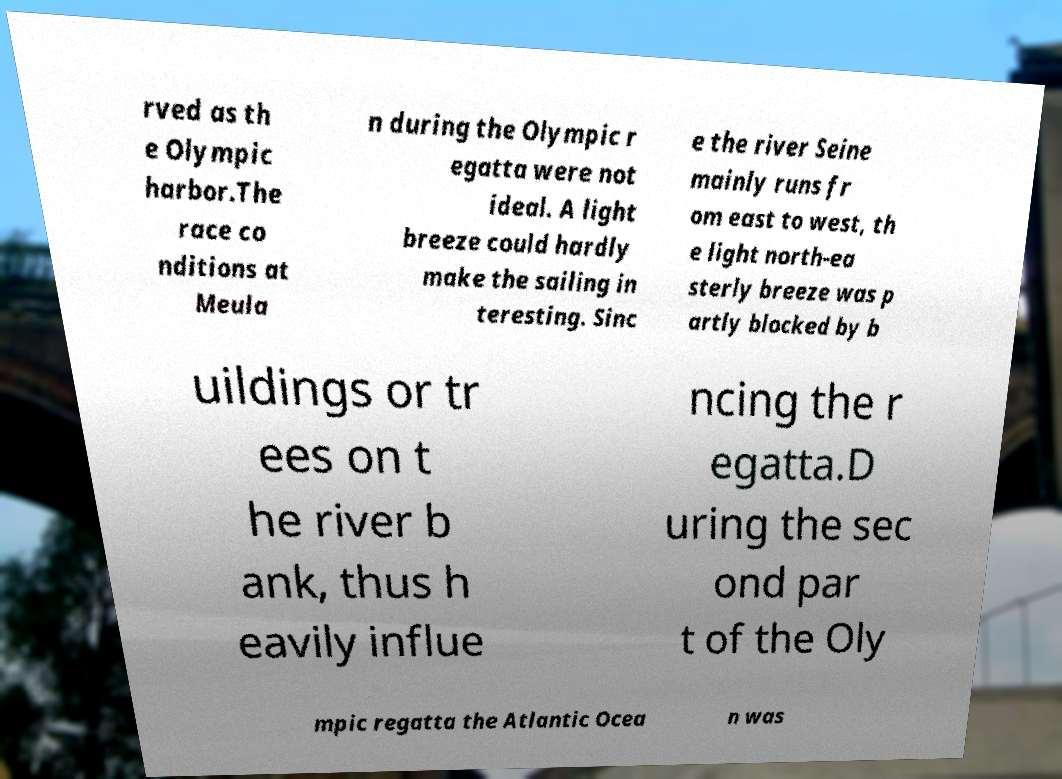There's text embedded in this image that I need extracted. Can you transcribe it verbatim? rved as th e Olympic harbor.The race co nditions at Meula n during the Olympic r egatta were not ideal. A light breeze could hardly make the sailing in teresting. Sinc e the river Seine mainly runs fr om east to west, th e light north-ea sterly breeze was p artly blocked by b uildings or tr ees on t he river b ank, thus h eavily influe ncing the r egatta.D uring the sec ond par t of the Oly mpic regatta the Atlantic Ocea n was 